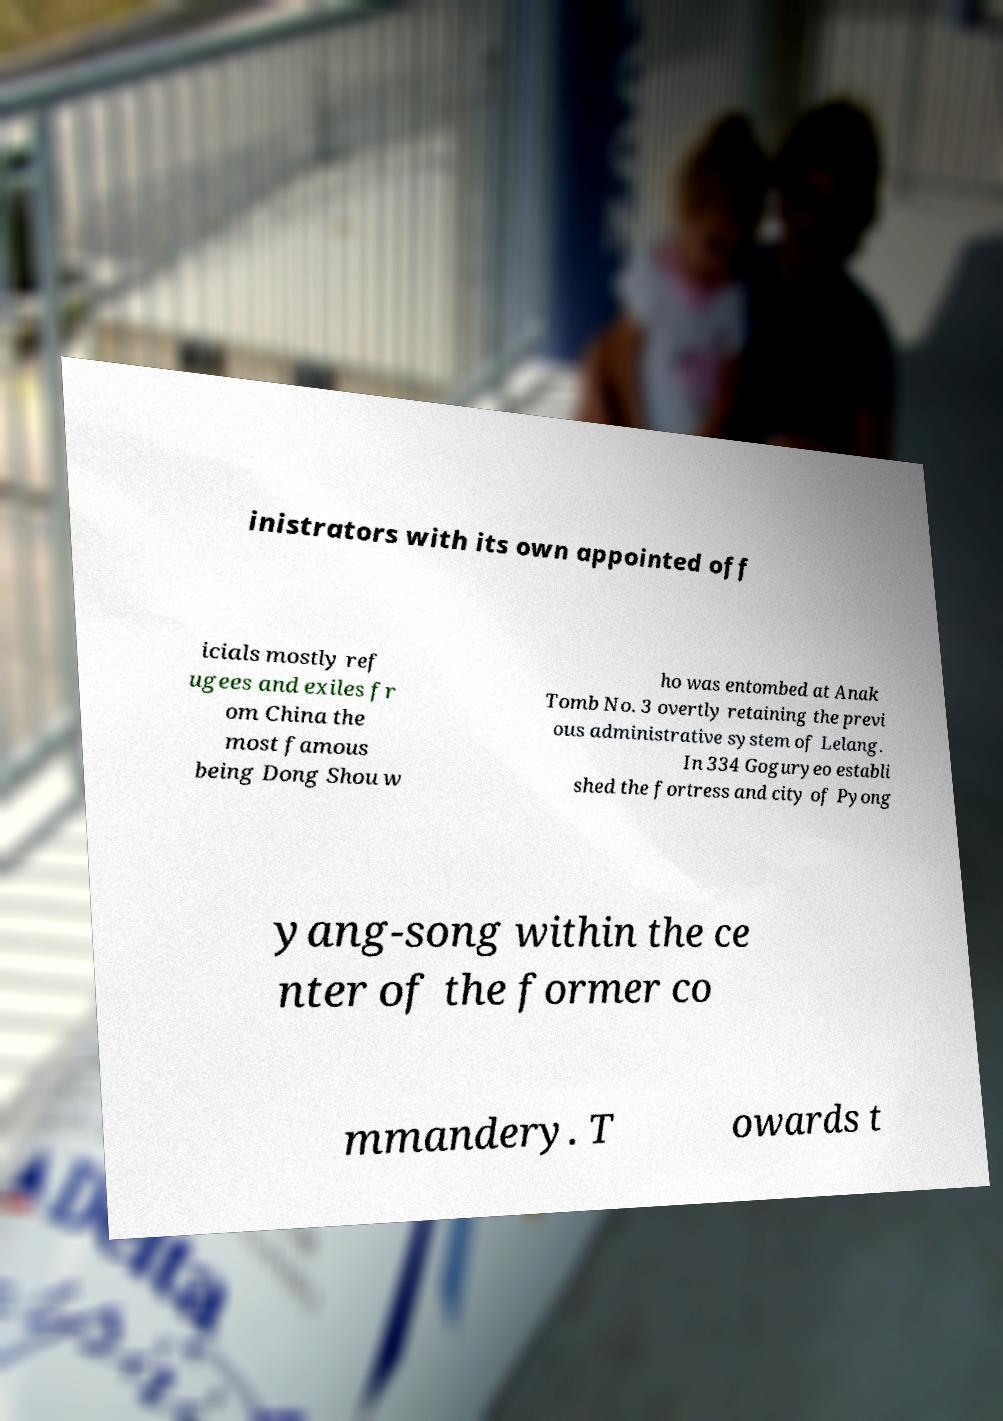Please read and relay the text visible in this image. What does it say? inistrators with its own appointed off icials mostly ref ugees and exiles fr om China the most famous being Dong Shou w ho was entombed at Anak Tomb No. 3 overtly retaining the previ ous administrative system of Lelang. In 334 Goguryeo establi shed the fortress and city of Pyong yang-song within the ce nter of the former co mmandery. T owards t 